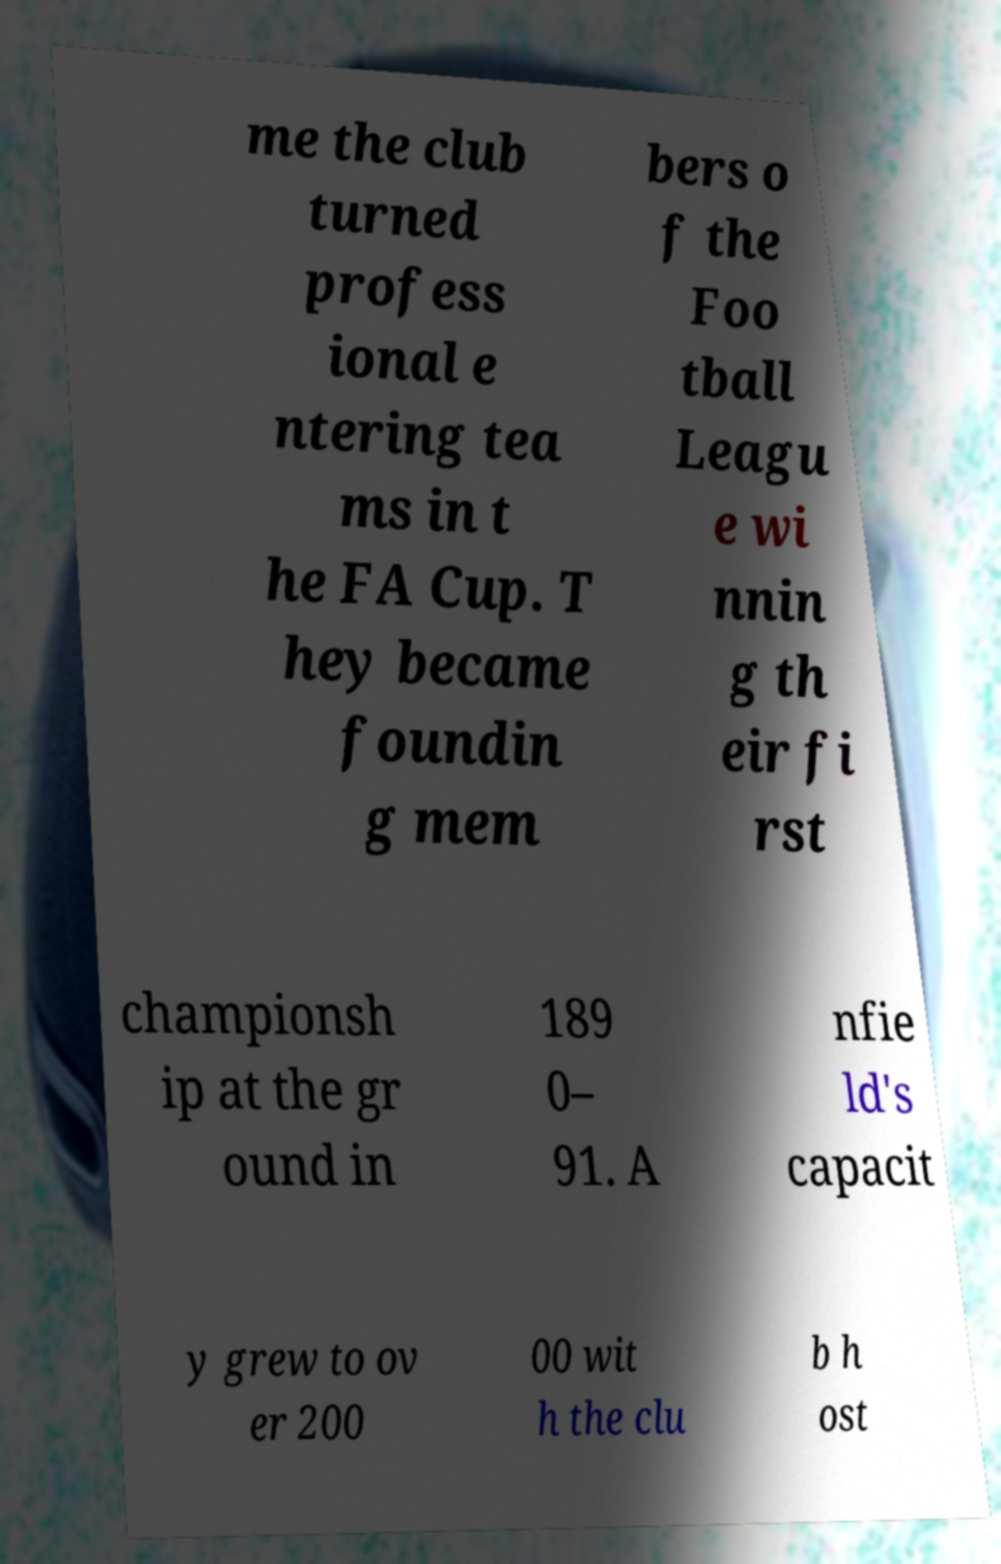Could you assist in decoding the text presented in this image and type it out clearly? me the club turned profess ional e ntering tea ms in t he FA Cup. T hey became foundin g mem bers o f the Foo tball Leagu e wi nnin g th eir fi rst championsh ip at the gr ound in 189 0– 91. A nfie ld's capacit y grew to ov er 200 00 wit h the clu b h ost 